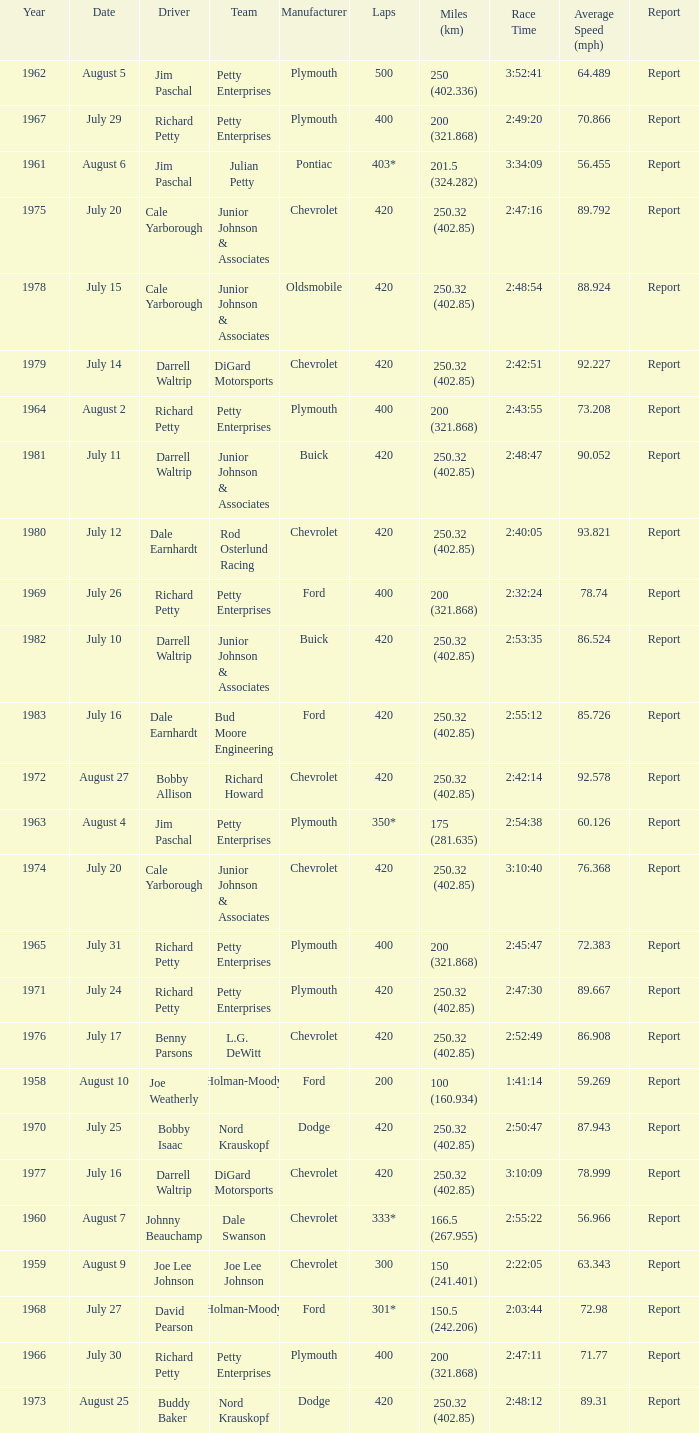How many races did Cale Yarborough win at an average speed of 88.924 mph? 1.0. 